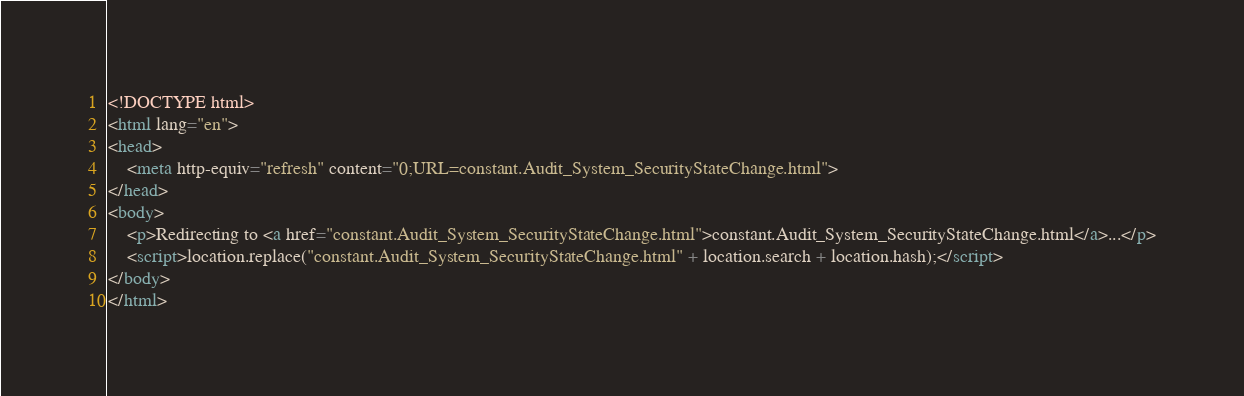<code> <loc_0><loc_0><loc_500><loc_500><_HTML_><!DOCTYPE html>
<html lang="en">
<head>
    <meta http-equiv="refresh" content="0;URL=constant.Audit_System_SecurityStateChange.html">
</head>
<body>
    <p>Redirecting to <a href="constant.Audit_System_SecurityStateChange.html">constant.Audit_System_SecurityStateChange.html</a>...</p>
    <script>location.replace("constant.Audit_System_SecurityStateChange.html" + location.search + location.hash);</script>
</body>
</html></code> 